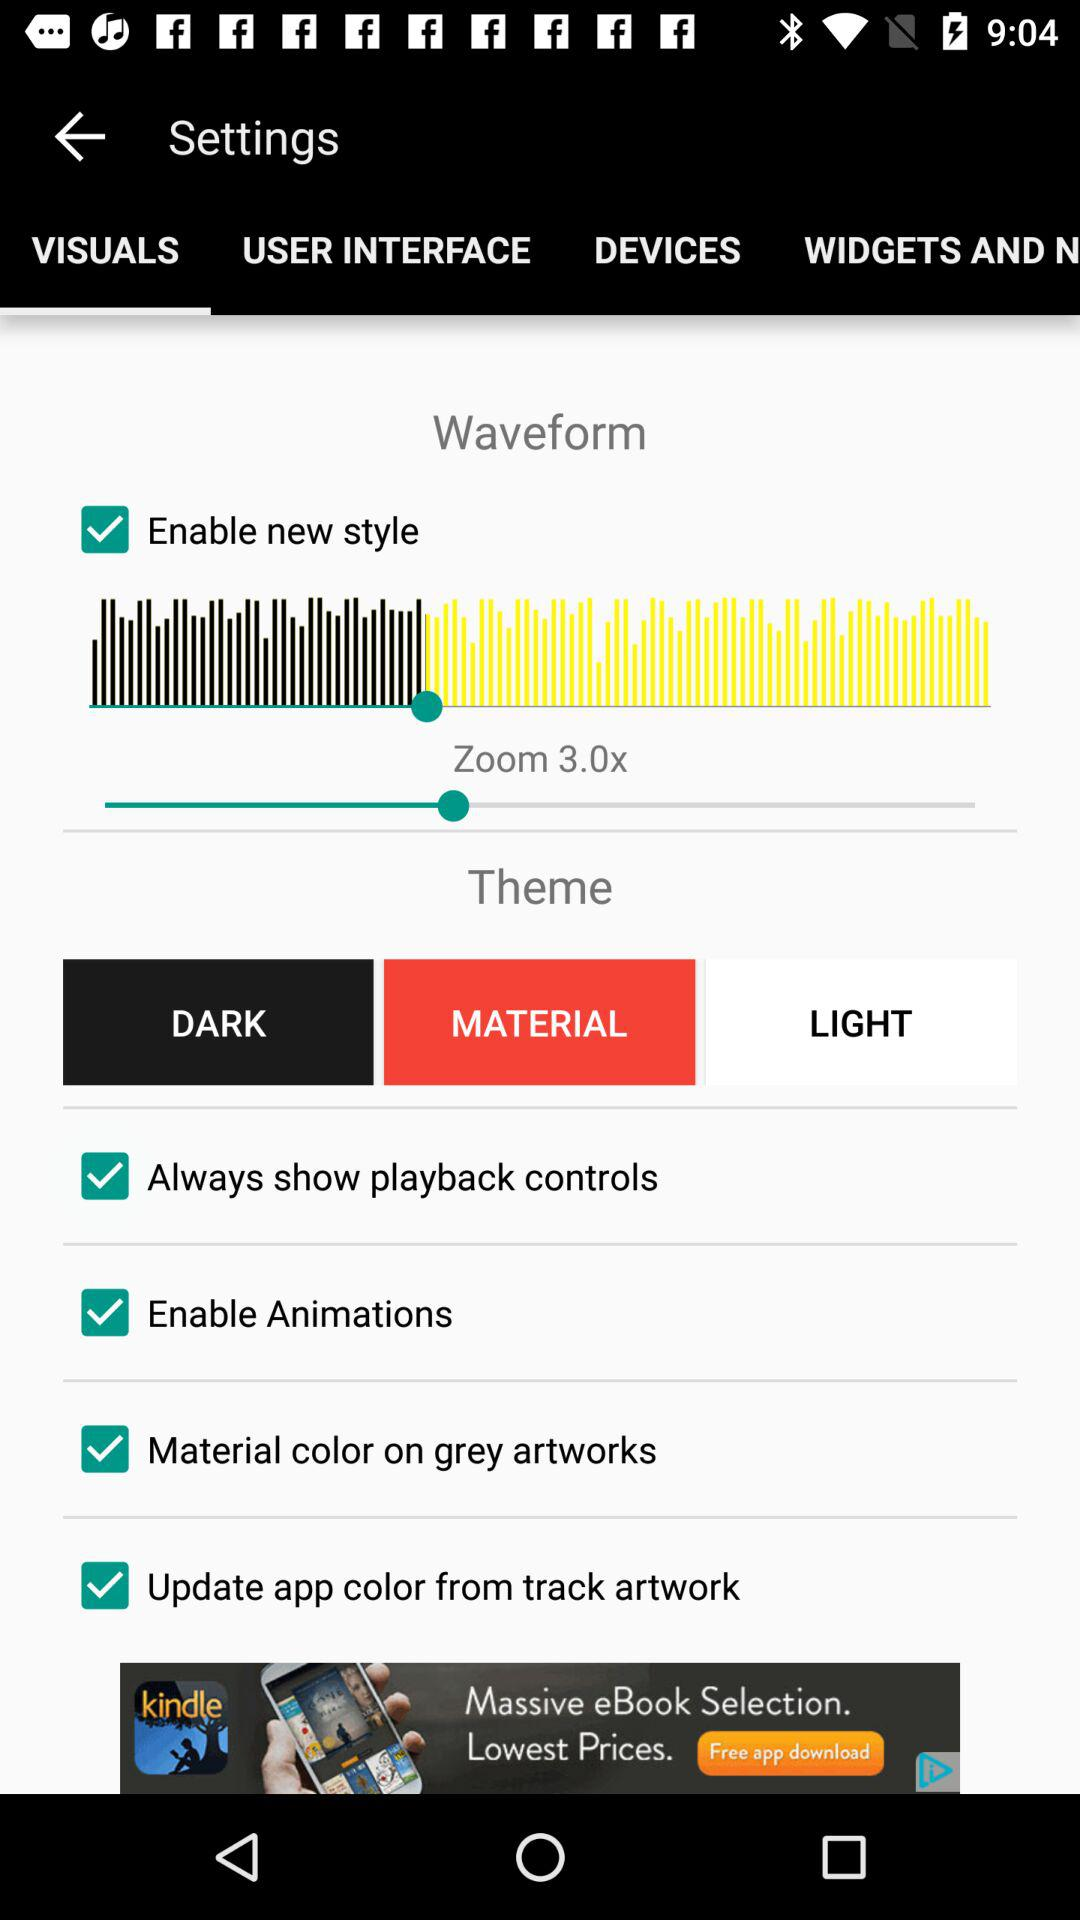What is the status of Enable Animations? The status is on. 